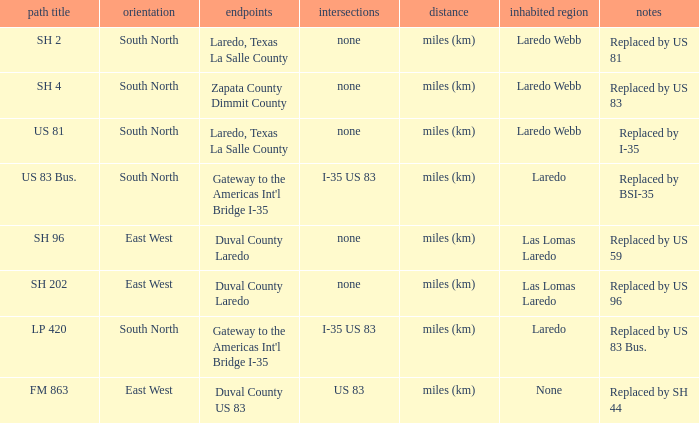What unit of length is being used for the route with "replaced by us 81" in their remarks section? Miles (km). 